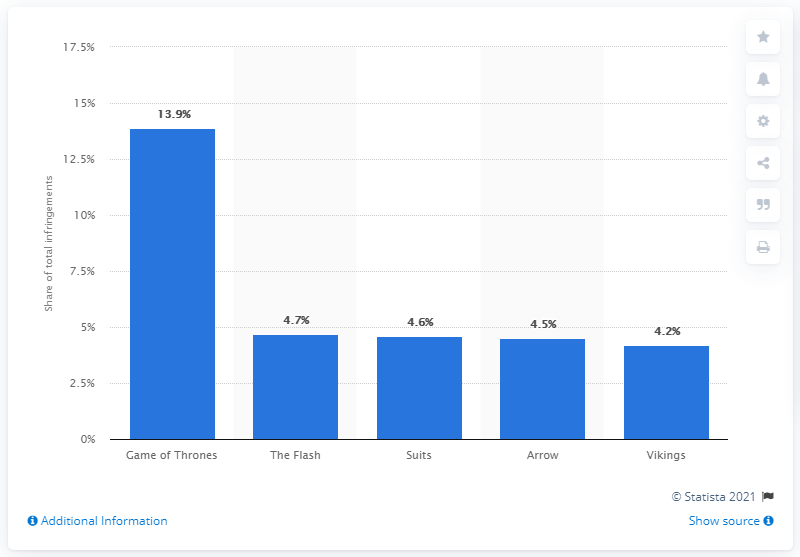Point out several critical features in this image. It was announced that the most pirated TV show in the third quarter of 2016 was "Game of Thrones. 